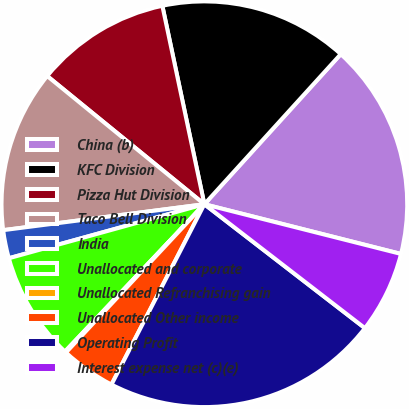Convert chart to OTSL. <chart><loc_0><loc_0><loc_500><loc_500><pie_chart><fcel>China (b)<fcel>KFC Division<fcel>Pizza Hut Division<fcel>Taco Bell Division<fcel>India<fcel>Unallocated and corporate<fcel>Unallocated Refranchising gain<fcel>Unallocated Other income<fcel>Operating Profit<fcel>Interest expense net (c)(e)<nl><fcel>17.2%<fcel>15.06%<fcel>10.79%<fcel>12.93%<fcel>2.25%<fcel>8.65%<fcel>0.11%<fcel>4.38%<fcel>22.11%<fcel>6.52%<nl></chart> 